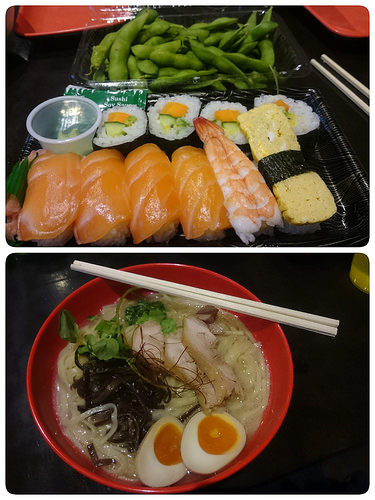<image>
Can you confirm if the sushi is to the left of the greens? No. The sushi is not to the left of the greens. From this viewpoint, they have a different horizontal relationship. 